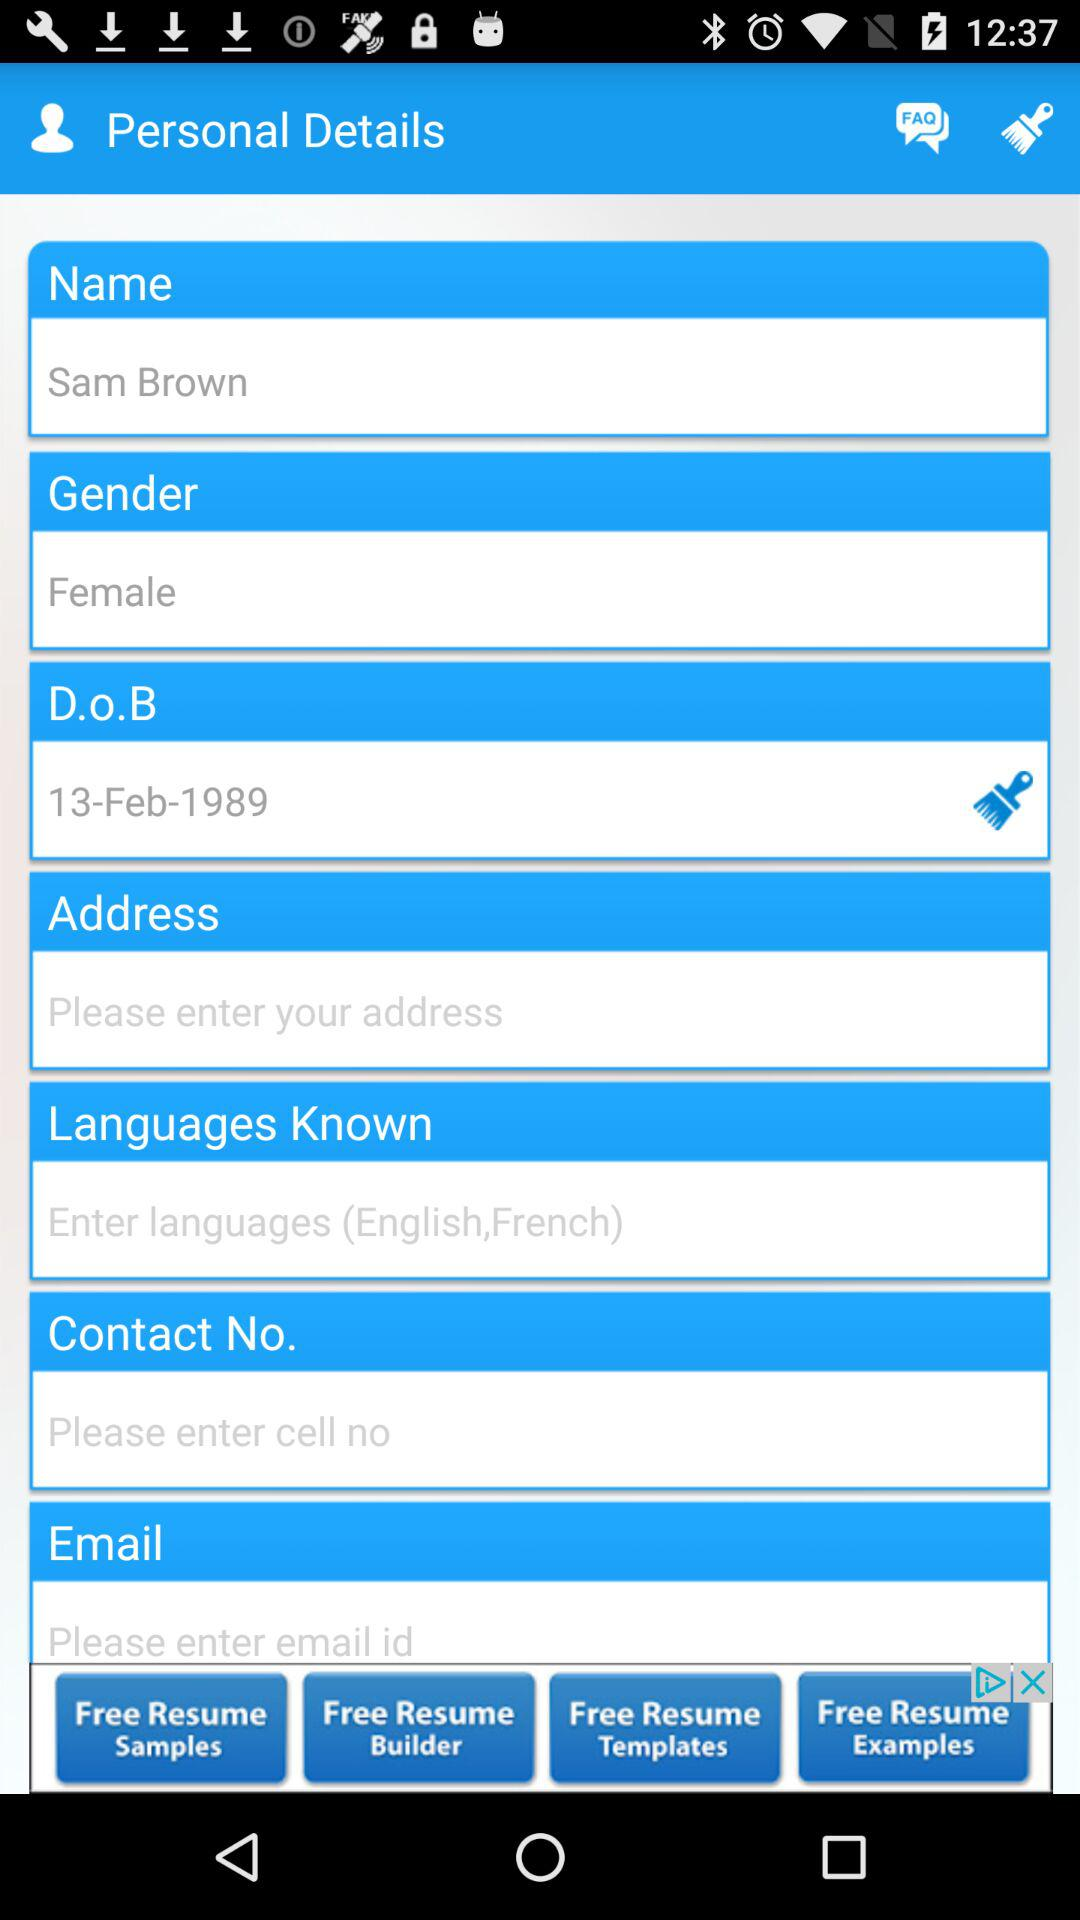What is the name? The name is Sam Brown. 